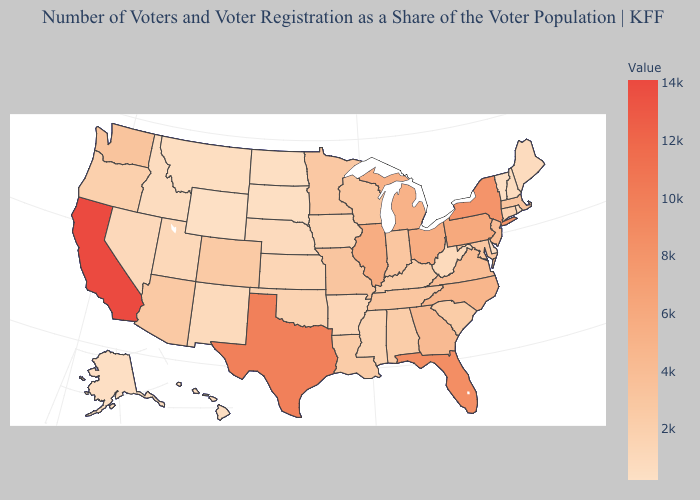Which states have the highest value in the USA?
Short answer required. California. Among the states that border Mississippi , which have the highest value?
Write a very short answer. Tennessee. Among the states that border South Carolina , does Georgia have the lowest value?
Keep it brief. Yes. Does Wyoming have the lowest value in the West?
Short answer required. Yes. Does Maryland have a lower value than Hawaii?
Short answer required. No. Among the states that border South Dakota , does Minnesota have the highest value?
Keep it brief. Yes. 